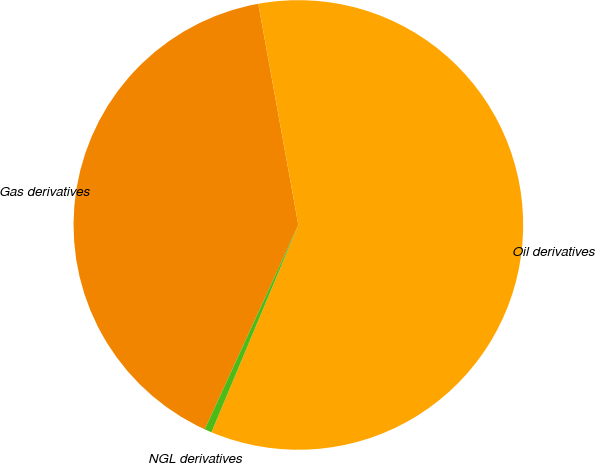Convert chart to OTSL. <chart><loc_0><loc_0><loc_500><loc_500><pie_chart><fcel>Gas derivatives<fcel>Oil derivatives<fcel>NGL derivatives<nl><fcel>40.31%<fcel>59.17%<fcel>0.52%<nl></chart> 